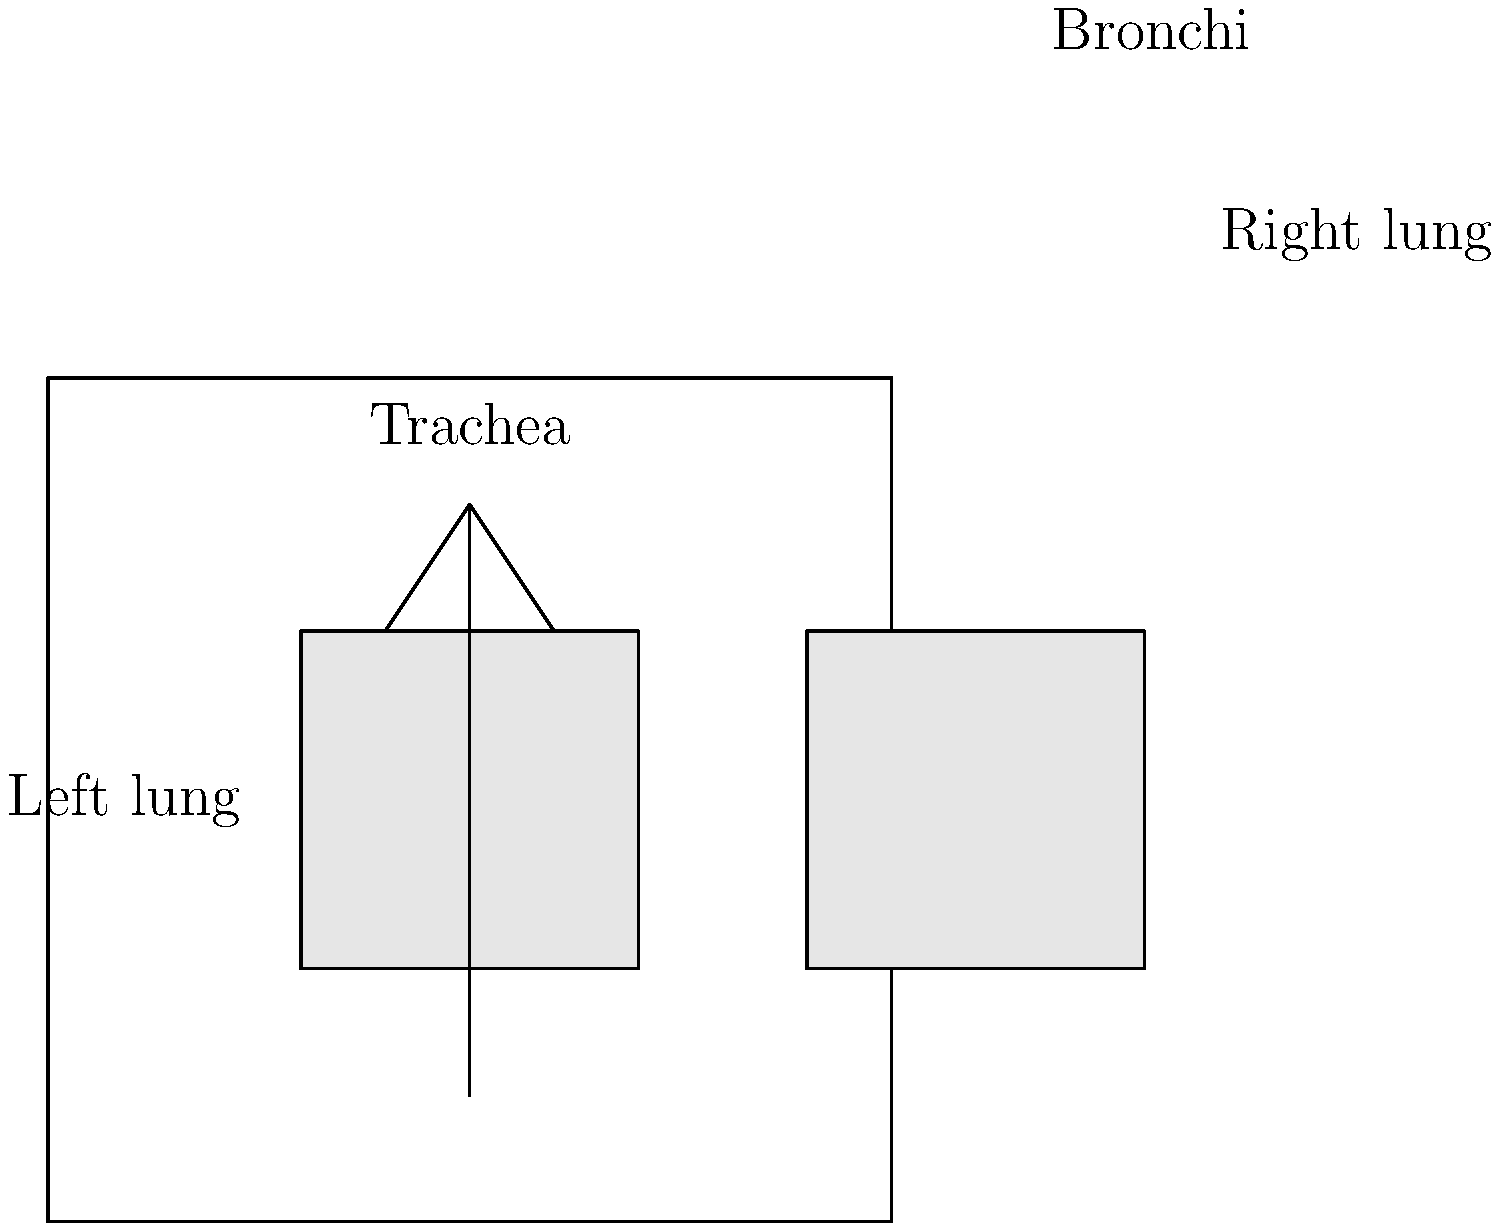In the diagram of the human respiratory system, which structure branches off from the trachea to deliver air into the lungs? To answer this question, let's analyze the structure of the respiratory system as shown in the diagram:

1. The diagram shows a simplified representation of the human respiratory system.
2. At the top of the diagram, we see a vertical tube labeled "Trachea." This is the main airway that carries air from the throat to the lungs.
3. As we follow the trachea downward, we observe that it splits into two smaller tubes, one going to each lung.
4. These two smaller tubes that branch off from the trachea are called the bronchi (singular: bronchus).
5. The bronchi are the main airways that deliver air directly into each lung.
6. In the diagram, we can see that these bronchi enter the top of each lung and continue to branch out (though not shown in detail) to distribute air throughout the lung tissue.

Therefore, the structures that branch off from the trachea to deliver air into the lungs are the bronchi.
Answer: Bronchi 